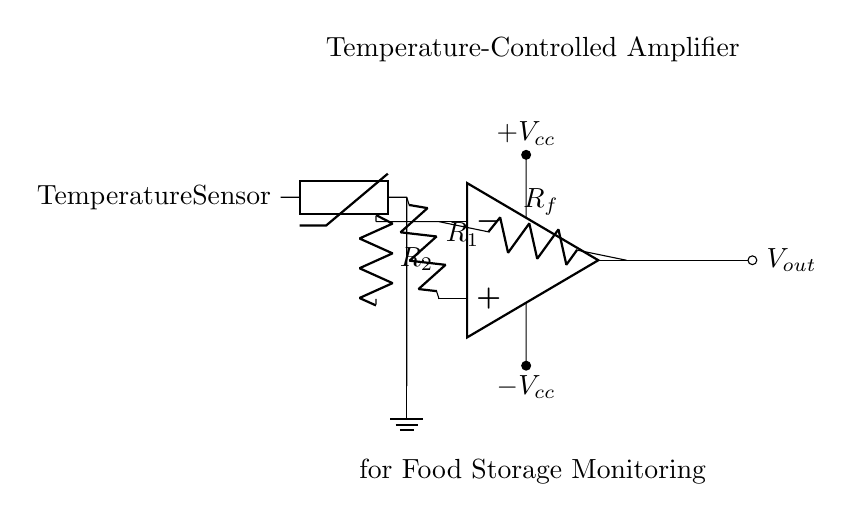What components are present in this circuit? The circuit includes an operational amplifier, a thermistor, and two resistors labeled R1, Rf, and R2.
Answer: operational amplifier, thermistor, resistors R1, Rf, R2 What role does the thermistor play in the circuit? The thermistor acts as a temperature sensor, providing a variable resistance that changes with temperature, which is used for monitoring.
Answer: temperature sensor What is the output of this amplifier circuit represented as? The output is labeled Vout, which denotes the amplified voltage that results from the operational amplifier's processing of the input signal.
Answer: Vout What happens if the resistance of R1 increases? Increasing R1's resistance will result in a smaller input voltage to the operational amplifier, potentially decreasing the output voltage depending on the feedback configuration.
Answer: decrease output voltage What kind of feedback is present in this amplifier circuit? The circuit features negative feedback, as indicated by the connection of output back to the inverting input through resistor Rf, stabilizing the gain.
Answer: negative feedback How many voltage supplies are there in this circuit? The circuit contains two voltage supplies, labeled as +Vcc and -Vcc, indicating a dual power supply setup for the operational amplifier.
Answer: two voltage supplies 